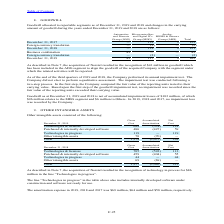According to Stmicroelectronics's financial document, What does Technologies in progress in the table include? includes internally developed software under construction and software not ready for use.. The document states: "“Technologies in progress” in the table above also includes internally developed software under construction and software not ready for use...." Also, How much was the amortization expense in 2019? According to the financial document, $69 million. The relevant text states: "he amortization expense in 2019, 2018 and 2017 was $69 million, $64 million and $58 million, respectively...." Also, How much was the amortization expense in 2018? According to the financial document, $64 million. The relevant text states: "on expense in 2019, 2018 and 2017 was $69 million, $64 million and $58 million, respectively...." Also, can you calculate: What is the average Gross Cost? To answer this question, I need to perform calculations using the financial data. The calculation is: (1,374+1,277) / 2, which equals 1325.5 (in millions). This is based on the information: "Total 1,277 (1,065) 212 Total 1,374 (1,075) 299..." The key data points involved are: 1,277, 1,374. Also, can you calculate: What is the average Accumulated Amortization? To answer this question, I need to perform calculations using the financial data. The calculation is: (1,075+1,065) / 2, which equals 1070 (in millions). This is based on the information: "Total 1,374 (1,075) 299 Total 1,277 (1,065) 212..." The key data points involved are: 1,065, 1,075. Also, can you calculate: What is the average Net Cost? To answer this question, I need to perform calculations using the financial data. The calculation is: (299+212) / 2, which equals 255.5 (in millions). This is based on the information: "Total 1,277 (1,065) 212 Total 1,374 (1,075) 299..." The key data points involved are: 212, 299. 